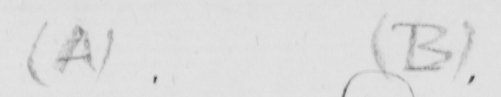What text is written in this handwritten line? ( A )   ( B ) 